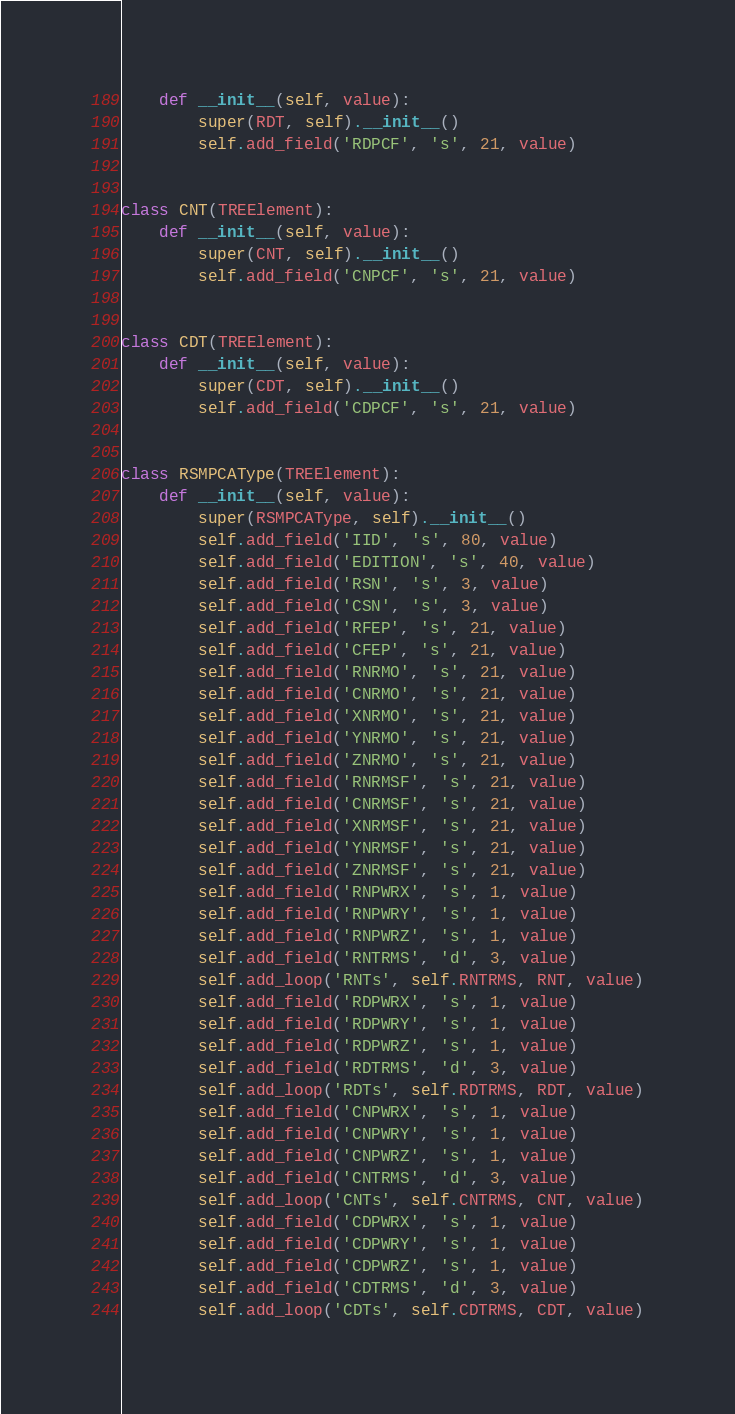<code> <loc_0><loc_0><loc_500><loc_500><_Python_>    def __init__(self, value):
        super(RDT, self).__init__()
        self.add_field('RDPCF', 's', 21, value)


class CNT(TREElement):
    def __init__(self, value):
        super(CNT, self).__init__()
        self.add_field('CNPCF', 's', 21, value)


class CDT(TREElement):
    def __init__(self, value):
        super(CDT, self).__init__()
        self.add_field('CDPCF', 's', 21, value)


class RSMPCAType(TREElement):
    def __init__(self, value):
        super(RSMPCAType, self).__init__()
        self.add_field('IID', 's', 80, value)
        self.add_field('EDITION', 's', 40, value)
        self.add_field('RSN', 's', 3, value)
        self.add_field('CSN', 's', 3, value)
        self.add_field('RFEP', 's', 21, value)
        self.add_field('CFEP', 's', 21, value)
        self.add_field('RNRMO', 's', 21, value)
        self.add_field('CNRMO', 's', 21, value)
        self.add_field('XNRMO', 's', 21, value)
        self.add_field('YNRMO', 's', 21, value)
        self.add_field('ZNRMO', 's', 21, value)
        self.add_field('RNRMSF', 's', 21, value)
        self.add_field('CNRMSF', 's', 21, value)
        self.add_field('XNRMSF', 's', 21, value)
        self.add_field('YNRMSF', 's', 21, value)
        self.add_field('ZNRMSF', 's', 21, value)
        self.add_field('RNPWRX', 's', 1, value)
        self.add_field('RNPWRY', 's', 1, value)
        self.add_field('RNPWRZ', 's', 1, value)
        self.add_field('RNTRMS', 'd', 3, value)
        self.add_loop('RNTs', self.RNTRMS, RNT, value)
        self.add_field('RDPWRX', 's', 1, value)
        self.add_field('RDPWRY', 's', 1, value)
        self.add_field('RDPWRZ', 's', 1, value)
        self.add_field('RDTRMS', 'd', 3, value)
        self.add_loop('RDTs', self.RDTRMS, RDT, value)
        self.add_field('CNPWRX', 's', 1, value)
        self.add_field('CNPWRY', 's', 1, value)
        self.add_field('CNPWRZ', 's', 1, value)
        self.add_field('CNTRMS', 'd', 3, value)
        self.add_loop('CNTs', self.CNTRMS, CNT, value)
        self.add_field('CDPWRX', 's', 1, value)
        self.add_field('CDPWRY', 's', 1, value)
        self.add_field('CDPWRZ', 's', 1, value)
        self.add_field('CDTRMS', 'd', 3, value)
        self.add_loop('CDTs', self.CDTRMS, CDT, value)

</code> 